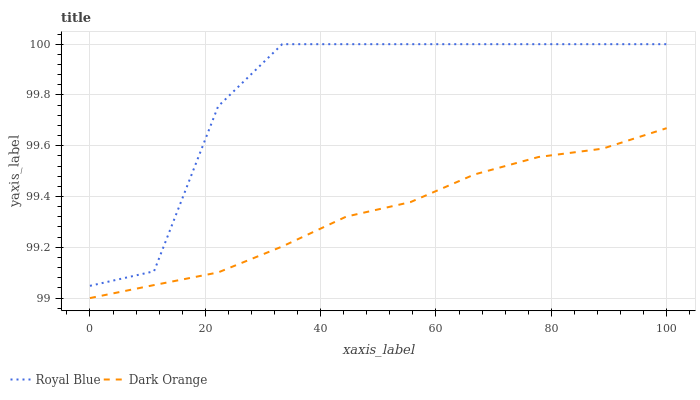Does Dark Orange have the minimum area under the curve?
Answer yes or no. Yes. Does Royal Blue have the maximum area under the curve?
Answer yes or no. Yes. Does Dark Orange have the maximum area under the curve?
Answer yes or no. No. Is Dark Orange the smoothest?
Answer yes or no. Yes. Is Royal Blue the roughest?
Answer yes or no. Yes. Is Dark Orange the roughest?
Answer yes or no. No. Does Dark Orange have the lowest value?
Answer yes or no. Yes. Does Royal Blue have the highest value?
Answer yes or no. Yes. Does Dark Orange have the highest value?
Answer yes or no. No. Is Dark Orange less than Royal Blue?
Answer yes or no. Yes. Is Royal Blue greater than Dark Orange?
Answer yes or no. Yes. Does Dark Orange intersect Royal Blue?
Answer yes or no. No. 